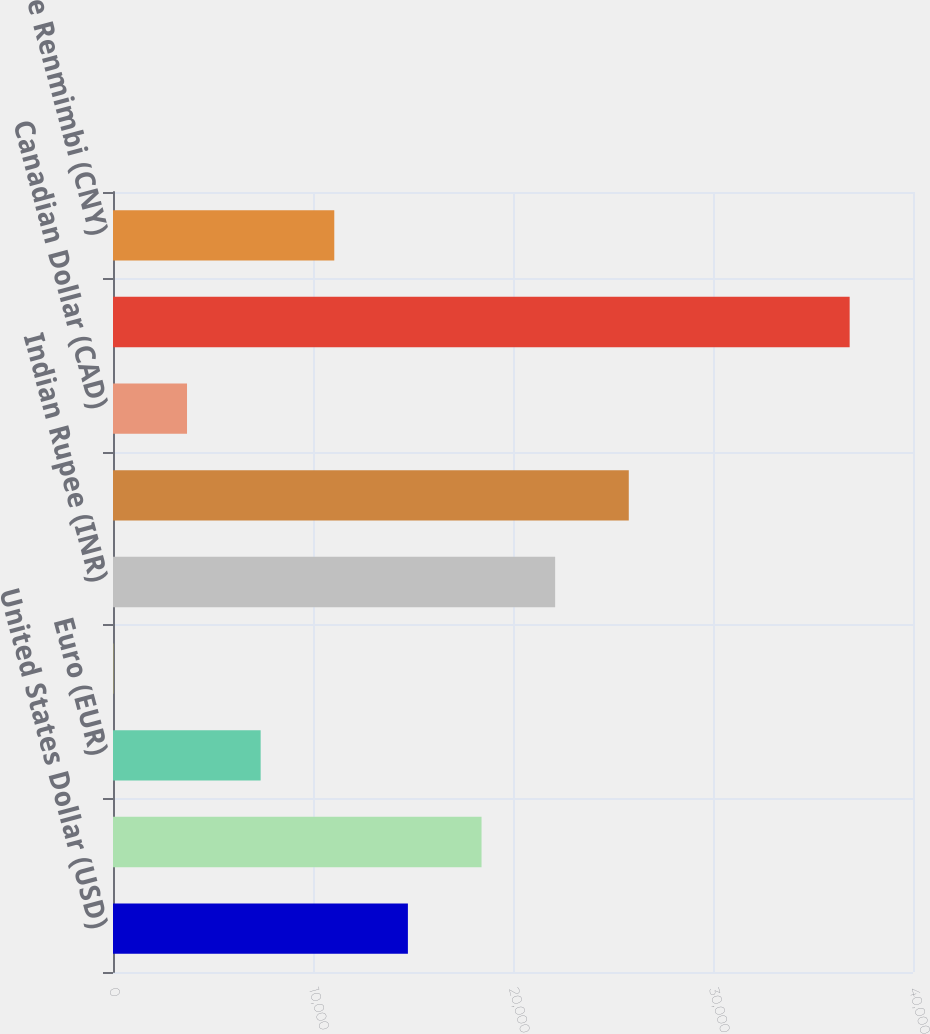<chart> <loc_0><loc_0><loc_500><loc_500><bar_chart><fcel>United States Dollar (USD)<fcel>British Pound Sterling (GBP)<fcel>Euro (EUR)<fcel>Singapore Dollar (SGD)<fcel>Indian Rupee (INR)<fcel>Japanese Yen (JPY)<fcel>Canadian Dollar (CAD)<fcel>South Korea Won (KRW)<fcel>Chinese Renmimbi (CNY)<nl><fcel>14745.2<fcel>18426.5<fcel>7382.6<fcel>20<fcel>22107.8<fcel>25789.1<fcel>3701.3<fcel>36833<fcel>11063.9<nl></chart> 